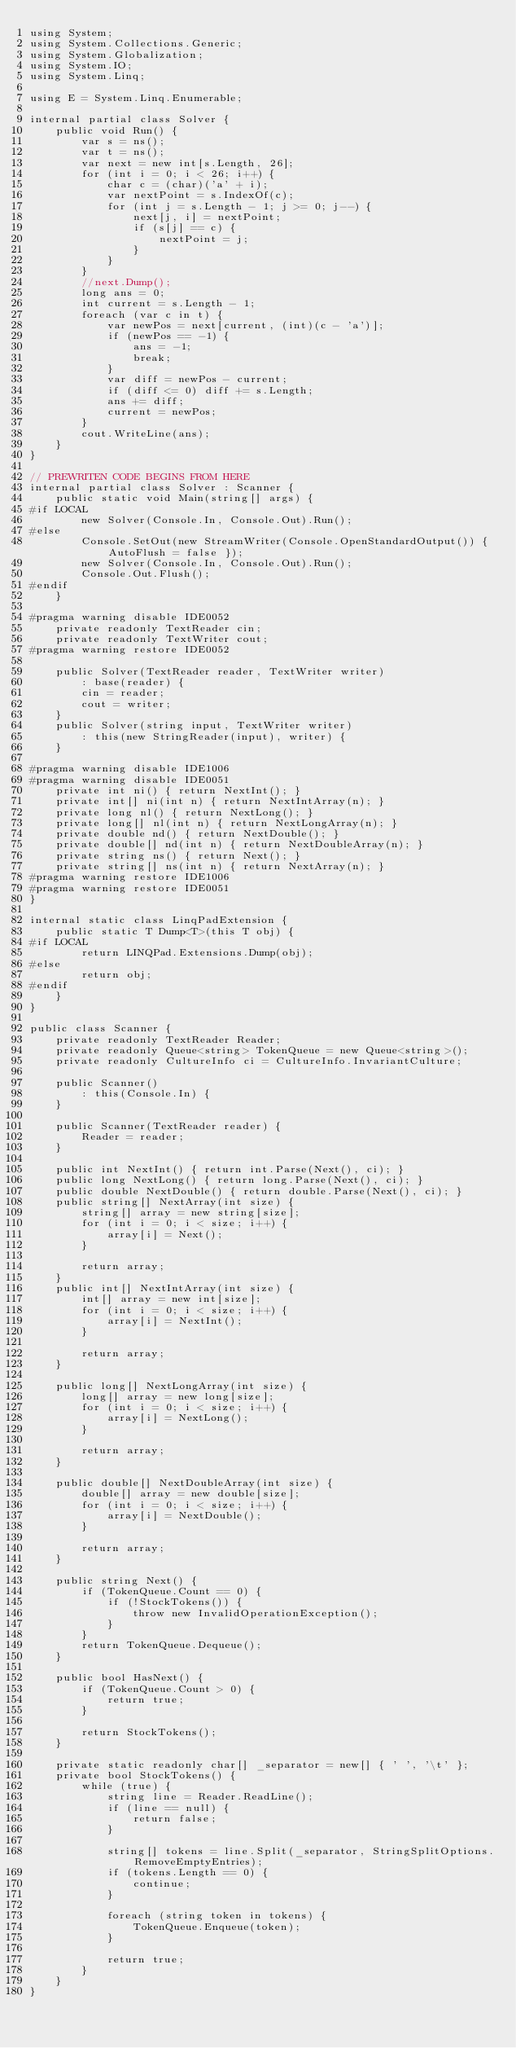<code> <loc_0><loc_0><loc_500><loc_500><_C#_>using System;
using System.Collections.Generic;
using System.Globalization;
using System.IO;
using System.Linq;

using E = System.Linq.Enumerable;

internal partial class Solver {
    public void Run() {
        var s = ns();
        var t = ns();
        var next = new int[s.Length, 26];
        for (int i = 0; i < 26; i++) {
            char c = (char)('a' + i);
            var nextPoint = s.IndexOf(c);
            for (int j = s.Length - 1; j >= 0; j--) {
                next[j, i] = nextPoint;
                if (s[j] == c) {
                    nextPoint = j;
                }
            }
        }
        //next.Dump();
        long ans = 0;
        int current = s.Length - 1;
        foreach (var c in t) {
            var newPos = next[current, (int)(c - 'a')];
            if (newPos == -1) {
                ans = -1;
                break;
            }
            var diff = newPos - current;
            if (diff <= 0) diff += s.Length;
            ans += diff;
            current = newPos;
        }
        cout.WriteLine(ans);
    }
}

// PREWRITEN CODE BEGINS FROM HERE
internal partial class Solver : Scanner {
    public static void Main(string[] args) {
#if LOCAL
        new Solver(Console.In, Console.Out).Run();
#else
        Console.SetOut(new StreamWriter(Console.OpenStandardOutput()) { AutoFlush = false });
        new Solver(Console.In, Console.Out).Run();
        Console.Out.Flush();
#endif
    }

#pragma warning disable IDE0052
    private readonly TextReader cin;
    private readonly TextWriter cout;
#pragma warning restore IDE0052

    public Solver(TextReader reader, TextWriter writer)
        : base(reader) {
        cin = reader;
        cout = writer;
    }
    public Solver(string input, TextWriter writer)
        : this(new StringReader(input), writer) {
    }

#pragma warning disable IDE1006
#pragma warning disable IDE0051
    private int ni() { return NextInt(); }
    private int[] ni(int n) { return NextIntArray(n); }
    private long nl() { return NextLong(); }
    private long[] nl(int n) { return NextLongArray(n); }
    private double nd() { return NextDouble(); }
    private double[] nd(int n) { return NextDoubleArray(n); }
    private string ns() { return Next(); }
    private string[] ns(int n) { return NextArray(n); }
#pragma warning restore IDE1006
#pragma warning restore IDE0051
}

internal static class LinqPadExtension {
    public static T Dump<T>(this T obj) {
#if LOCAL
        return LINQPad.Extensions.Dump(obj);
#else
        return obj;
#endif
    }
}

public class Scanner {
    private readonly TextReader Reader;
    private readonly Queue<string> TokenQueue = new Queue<string>();
    private readonly CultureInfo ci = CultureInfo.InvariantCulture;

    public Scanner()
        : this(Console.In) {
    }

    public Scanner(TextReader reader) {
        Reader = reader;
    }

    public int NextInt() { return int.Parse(Next(), ci); }
    public long NextLong() { return long.Parse(Next(), ci); }
    public double NextDouble() { return double.Parse(Next(), ci); }
    public string[] NextArray(int size) {
        string[] array = new string[size];
        for (int i = 0; i < size; i++) {
            array[i] = Next();
        }

        return array;
    }
    public int[] NextIntArray(int size) {
        int[] array = new int[size];
        for (int i = 0; i < size; i++) {
            array[i] = NextInt();
        }

        return array;
    }

    public long[] NextLongArray(int size) {
        long[] array = new long[size];
        for (int i = 0; i < size; i++) {
            array[i] = NextLong();
        }

        return array;
    }

    public double[] NextDoubleArray(int size) {
        double[] array = new double[size];
        for (int i = 0; i < size; i++) {
            array[i] = NextDouble();
        }

        return array;
    }

    public string Next() {
        if (TokenQueue.Count == 0) {
            if (!StockTokens()) {
                throw new InvalidOperationException();
            }
        }
        return TokenQueue.Dequeue();
    }

    public bool HasNext() {
        if (TokenQueue.Count > 0) {
            return true;
        }

        return StockTokens();
    }

    private static readonly char[] _separator = new[] { ' ', '\t' };
    private bool StockTokens() {
        while (true) {
            string line = Reader.ReadLine();
            if (line == null) {
                return false;
            }

            string[] tokens = line.Split(_separator, StringSplitOptions.RemoveEmptyEntries);
            if (tokens.Length == 0) {
                continue;
            }

            foreach (string token in tokens) {
                TokenQueue.Enqueue(token);
            }

            return true;
        }
    }
}
</code> 